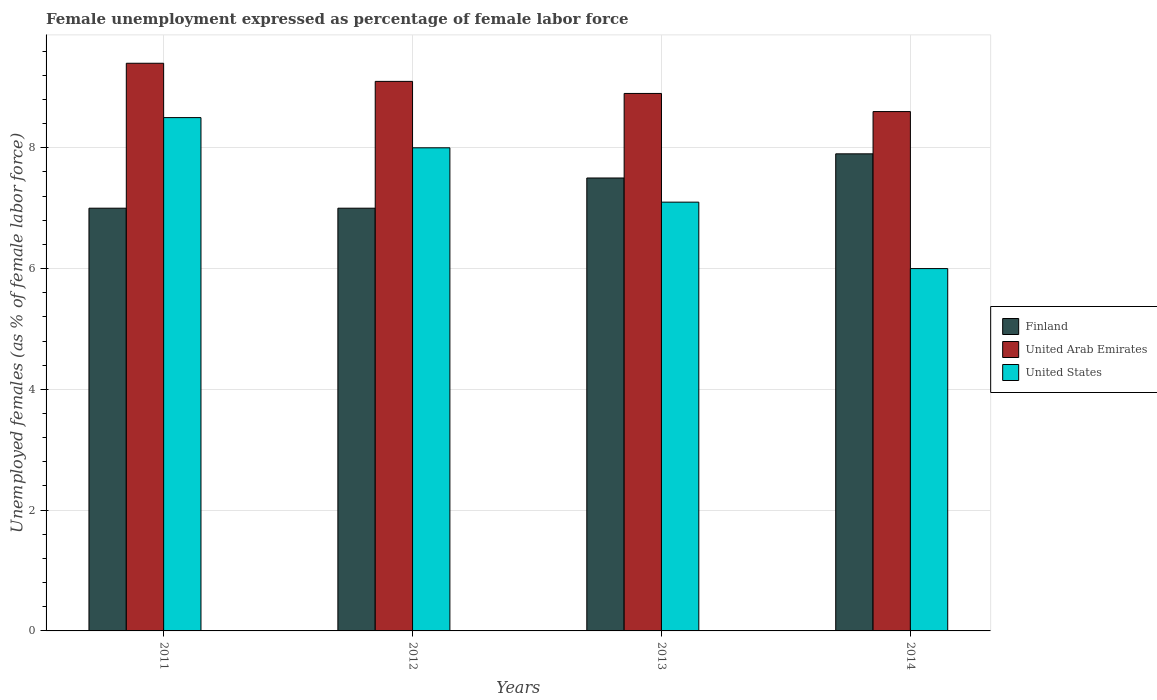How many different coloured bars are there?
Provide a succinct answer. 3. Are the number of bars on each tick of the X-axis equal?
Give a very brief answer. Yes. In how many cases, is the number of bars for a given year not equal to the number of legend labels?
Ensure brevity in your answer.  0. What is the unemployment in females in in United Arab Emirates in 2013?
Your response must be concise. 8.9. Across all years, what is the maximum unemployment in females in in United Arab Emirates?
Offer a terse response. 9.4. Across all years, what is the minimum unemployment in females in in United States?
Keep it short and to the point. 6. What is the total unemployment in females in in Finland in the graph?
Offer a terse response. 29.4. What is the difference between the unemployment in females in in United States in 2013 and that in 2014?
Offer a terse response. 1.1. What is the difference between the unemployment in females in in Finland in 2011 and the unemployment in females in in United States in 2014?
Offer a terse response. 1. What is the average unemployment in females in in United Arab Emirates per year?
Make the answer very short. 9. In the year 2014, what is the difference between the unemployment in females in in United Arab Emirates and unemployment in females in in Finland?
Your response must be concise. 0.7. What is the ratio of the unemployment in females in in United States in 2012 to that in 2013?
Offer a terse response. 1.13. What is the difference between the highest and the second highest unemployment in females in in United States?
Provide a short and direct response. 0.5. What is the difference between the highest and the lowest unemployment in females in in United Arab Emirates?
Give a very brief answer. 0.8. In how many years, is the unemployment in females in in United States greater than the average unemployment in females in in United States taken over all years?
Keep it short and to the point. 2. Is the sum of the unemployment in females in in United States in 2012 and 2014 greater than the maximum unemployment in females in in United Arab Emirates across all years?
Provide a short and direct response. Yes. What does the 2nd bar from the left in 2014 represents?
Provide a succinct answer. United Arab Emirates. What does the 1st bar from the right in 2014 represents?
Your answer should be very brief. United States. Are all the bars in the graph horizontal?
Provide a short and direct response. No. What is the difference between two consecutive major ticks on the Y-axis?
Offer a terse response. 2. Does the graph contain any zero values?
Keep it short and to the point. No. Does the graph contain grids?
Provide a short and direct response. Yes. What is the title of the graph?
Offer a very short reply. Female unemployment expressed as percentage of female labor force. What is the label or title of the Y-axis?
Your answer should be very brief. Unemployed females (as % of female labor force). What is the Unemployed females (as % of female labor force) in Finland in 2011?
Your answer should be compact. 7. What is the Unemployed females (as % of female labor force) in United Arab Emirates in 2011?
Provide a succinct answer. 9.4. What is the Unemployed females (as % of female labor force) in United States in 2011?
Your response must be concise. 8.5. What is the Unemployed females (as % of female labor force) of United Arab Emirates in 2012?
Offer a very short reply. 9.1. What is the Unemployed females (as % of female labor force) of United States in 2012?
Your answer should be very brief. 8. What is the Unemployed females (as % of female labor force) in Finland in 2013?
Your answer should be very brief. 7.5. What is the Unemployed females (as % of female labor force) in United Arab Emirates in 2013?
Ensure brevity in your answer.  8.9. What is the Unemployed females (as % of female labor force) in United States in 2013?
Offer a terse response. 7.1. What is the Unemployed females (as % of female labor force) of Finland in 2014?
Keep it short and to the point. 7.9. What is the Unemployed females (as % of female labor force) of United Arab Emirates in 2014?
Give a very brief answer. 8.6. What is the Unemployed females (as % of female labor force) in United States in 2014?
Your answer should be compact. 6. Across all years, what is the maximum Unemployed females (as % of female labor force) in Finland?
Provide a short and direct response. 7.9. Across all years, what is the maximum Unemployed females (as % of female labor force) in United Arab Emirates?
Your answer should be compact. 9.4. Across all years, what is the maximum Unemployed females (as % of female labor force) in United States?
Your answer should be very brief. 8.5. Across all years, what is the minimum Unemployed females (as % of female labor force) in United Arab Emirates?
Make the answer very short. 8.6. What is the total Unemployed females (as % of female labor force) of Finland in the graph?
Your answer should be very brief. 29.4. What is the total Unemployed females (as % of female labor force) in United States in the graph?
Offer a very short reply. 29.6. What is the difference between the Unemployed females (as % of female labor force) in Finland in 2011 and that in 2013?
Your response must be concise. -0.5. What is the difference between the Unemployed females (as % of female labor force) of United States in 2011 and that in 2013?
Offer a terse response. 1.4. What is the difference between the Unemployed females (as % of female labor force) in United Arab Emirates in 2011 and that in 2014?
Your answer should be very brief. 0.8. What is the difference between the Unemployed females (as % of female labor force) in United Arab Emirates in 2013 and that in 2014?
Provide a short and direct response. 0.3. What is the difference between the Unemployed females (as % of female labor force) of United States in 2013 and that in 2014?
Your response must be concise. 1.1. What is the difference between the Unemployed females (as % of female labor force) of Finland in 2011 and the Unemployed females (as % of female labor force) of United States in 2012?
Make the answer very short. -1. What is the difference between the Unemployed females (as % of female labor force) of United Arab Emirates in 2011 and the Unemployed females (as % of female labor force) of United States in 2012?
Provide a succinct answer. 1.4. What is the difference between the Unemployed females (as % of female labor force) of United Arab Emirates in 2011 and the Unemployed females (as % of female labor force) of United States in 2013?
Give a very brief answer. 2.3. What is the difference between the Unemployed females (as % of female labor force) of Finland in 2011 and the Unemployed females (as % of female labor force) of United States in 2014?
Your response must be concise. 1. What is the difference between the Unemployed females (as % of female labor force) in United Arab Emirates in 2011 and the Unemployed females (as % of female labor force) in United States in 2014?
Your answer should be very brief. 3.4. What is the difference between the Unemployed females (as % of female labor force) in United Arab Emirates in 2012 and the Unemployed females (as % of female labor force) in United States in 2013?
Provide a succinct answer. 2. What is the difference between the Unemployed females (as % of female labor force) in Finland in 2012 and the Unemployed females (as % of female labor force) in United Arab Emirates in 2014?
Provide a succinct answer. -1.6. What is the difference between the Unemployed females (as % of female labor force) in United Arab Emirates in 2012 and the Unemployed females (as % of female labor force) in United States in 2014?
Provide a succinct answer. 3.1. What is the difference between the Unemployed females (as % of female labor force) in Finland in 2013 and the Unemployed females (as % of female labor force) in United Arab Emirates in 2014?
Offer a terse response. -1.1. What is the difference between the Unemployed females (as % of female labor force) in Finland in 2013 and the Unemployed females (as % of female labor force) in United States in 2014?
Your answer should be compact. 1.5. What is the average Unemployed females (as % of female labor force) of Finland per year?
Your answer should be compact. 7.35. What is the average Unemployed females (as % of female labor force) of United Arab Emirates per year?
Offer a very short reply. 9. What is the average Unemployed females (as % of female labor force) of United States per year?
Provide a succinct answer. 7.4. In the year 2011, what is the difference between the Unemployed females (as % of female labor force) in Finland and Unemployed females (as % of female labor force) in United Arab Emirates?
Provide a short and direct response. -2.4. In the year 2011, what is the difference between the Unemployed females (as % of female labor force) in Finland and Unemployed females (as % of female labor force) in United States?
Provide a short and direct response. -1.5. In the year 2011, what is the difference between the Unemployed females (as % of female labor force) of United Arab Emirates and Unemployed females (as % of female labor force) of United States?
Make the answer very short. 0.9. In the year 2013, what is the difference between the Unemployed females (as % of female labor force) of Finland and Unemployed females (as % of female labor force) of United Arab Emirates?
Offer a terse response. -1.4. In the year 2013, what is the difference between the Unemployed females (as % of female labor force) of United Arab Emirates and Unemployed females (as % of female labor force) of United States?
Provide a short and direct response. 1.8. In the year 2014, what is the difference between the Unemployed females (as % of female labor force) of United Arab Emirates and Unemployed females (as % of female labor force) of United States?
Provide a short and direct response. 2.6. What is the ratio of the Unemployed females (as % of female labor force) of United Arab Emirates in 2011 to that in 2012?
Offer a terse response. 1.03. What is the ratio of the Unemployed females (as % of female labor force) of United States in 2011 to that in 2012?
Offer a terse response. 1.06. What is the ratio of the Unemployed females (as % of female labor force) in United Arab Emirates in 2011 to that in 2013?
Offer a terse response. 1.06. What is the ratio of the Unemployed females (as % of female labor force) of United States in 2011 to that in 2013?
Your answer should be very brief. 1.2. What is the ratio of the Unemployed females (as % of female labor force) in Finland in 2011 to that in 2014?
Offer a terse response. 0.89. What is the ratio of the Unemployed females (as % of female labor force) of United Arab Emirates in 2011 to that in 2014?
Your answer should be very brief. 1.09. What is the ratio of the Unemployed females (as % of female labor force) of United States in 2011 to that in 2014?
Your answer should be compact. 1.42. What is the ratio of the Unemployed females (as % of female labor force) in Finland in 2012 to that in 2013?
Offer a terse response. 0.93. What is the ratio of the Unemployed females (as % of female labor force) of United Arab Emirates in 2012 to that in 2013?
Offer a terse response. 1.02. What is the ratio of the Unemployed females (as % of female labor force) of United States in 2012 to that in 2013?
Your response must be concise. 1.13. What is the ratio of the Unemployed females (as % of female labor force) of Finland in 2012 to that in 2014?
Give a very brief answer. 0.89. What is the ratio of the Unemployed females (as % of female labor force) of United Arab Emirates in 2012 to that in 2014?
Your answer should be compact. 1.06. What is the ratio of the Unemployed females (as % of female labor force) in United States in 2012 to that in 2014?
Provide a short and direct response. 1.33. What is the ratio of the Unemployed females (as % of female labor force) of Finland in 2013 to that in 2014?
Your answer should be very brief. 0.95. What is the ratio of the Unemployed females (as % of female labor force) of United Arab Emirates in 2013 to that in 2014?
Offer a terse response. 1.03. What is the ratio of the Unemployed females (as % of female labor force) of United States in 2013 to that in 2014?
Keep it short and to the point. 1.18. What is the difference between the highest and the second highest Unemployed females (as % of female labor force) of Finland?
Offer a very short reply. 0.4. What is the difference between the highest and the second highest Unemployed females (as % of female labor force) in United States?
Ensure brevity in your answer.  0.5. What is the difference between the highest and the lowest Unemployed females (as % of female labor force) in United States?
Your answer should be compact. 2.5. 